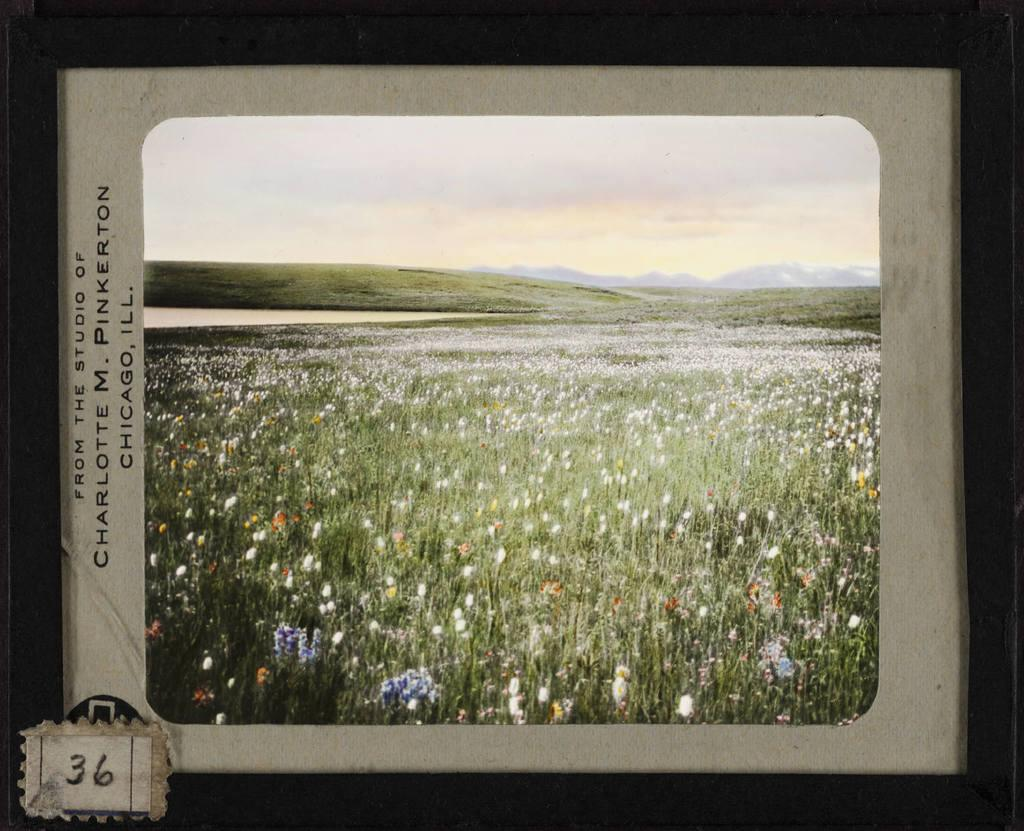Provide a one-sentence caption for the provided image. A picture of a field from the studio of Charlotte M. Pinkerton. 